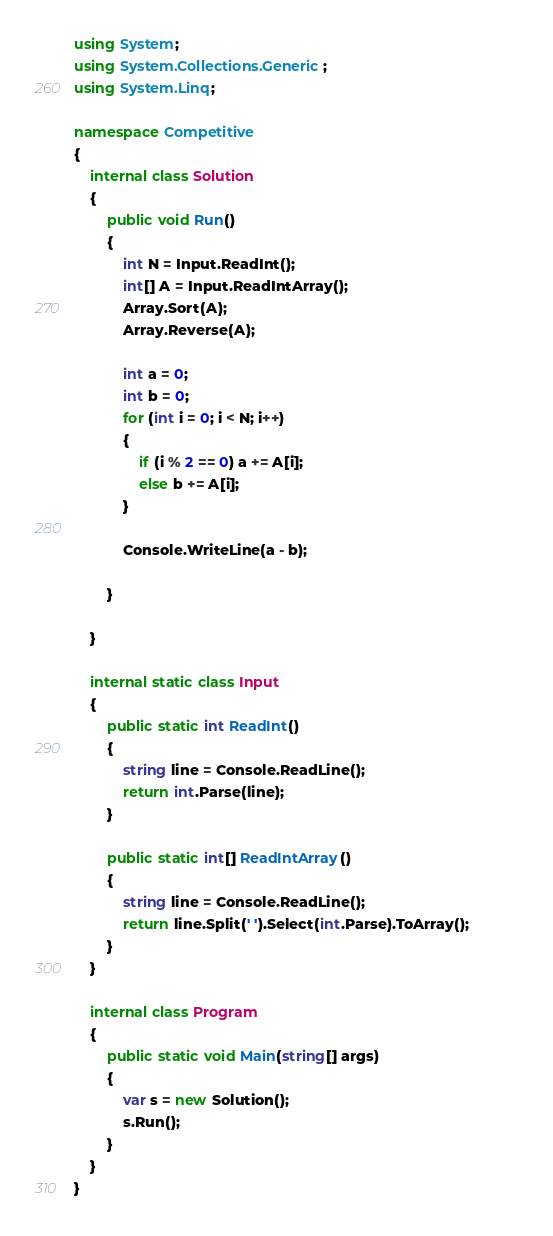Convert code to text. <code><loc_0><loc_0><loc_500><loc_500><_C#_>using System;
using System.Collections.Generic;
using System.Linq;

namespace Competitive
{
    internal class Solution
    {
        public void Run()
        {
            int N = Input.ReadInt();
            int[] A = Input.ReadIntArray();
            Array.Sort(A);
            Array.Reverse(A);

            int a = 0;
            int b = 0;
            for (int i = 0; i < N; i++)
            {
                if (i % 2 == 0) a += A[i];
                else b += A[i];
            }

            Console.WriteLine(a - b);

        }

    }

    internal static class Input
    {
        public static int ReadInt()
        {
            string line = Console.ReadLine();
            return int.Parse(line);
        }

        public static int[] ReadIntArray()
        {
            string line = Console.ReadLine();
            return line.Split(' ').Select(int.Parse).ToArray();            
        }
    }

    internal class Program
    {
        public static void Main(string[] args)
        {
            var s = new Solution();
            s.Run();
        }
    }
}</code> 